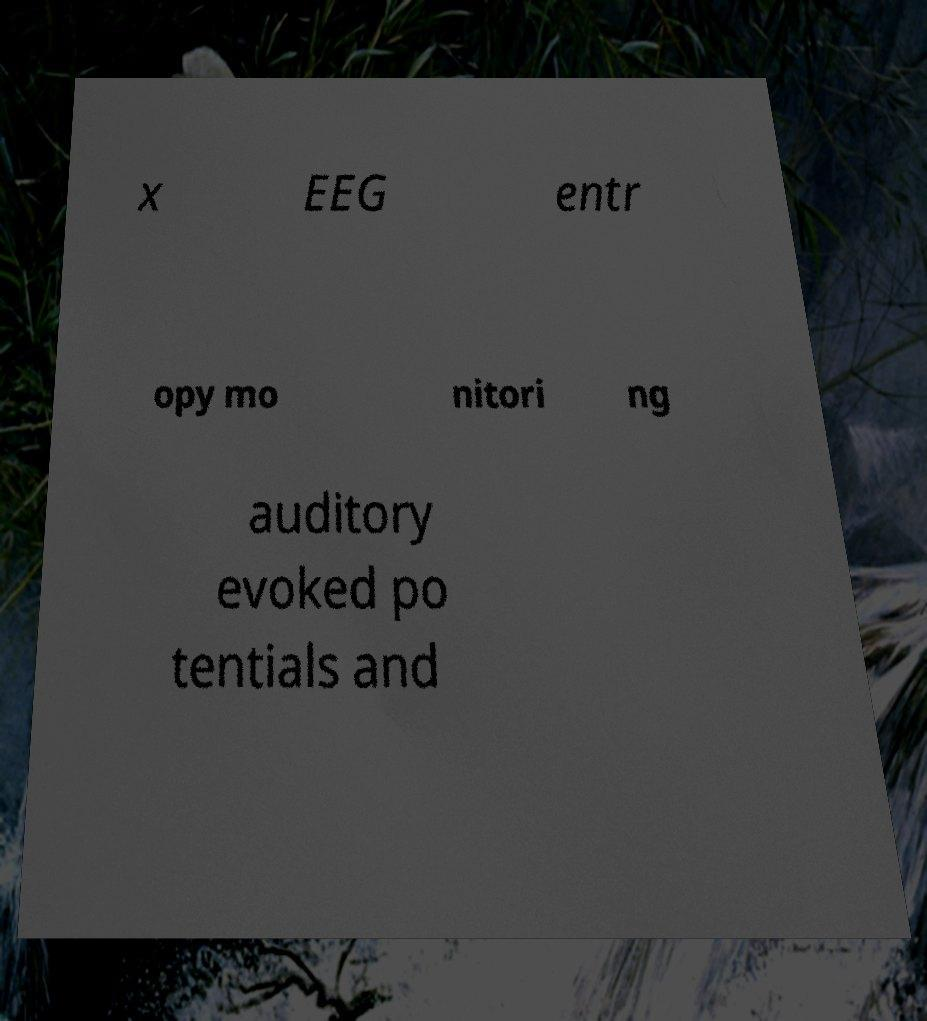Could you assist in decoding the text presented in this image and type it out clearly? x EEG entr opy mo nitori ng auditory evoked po tentials and 